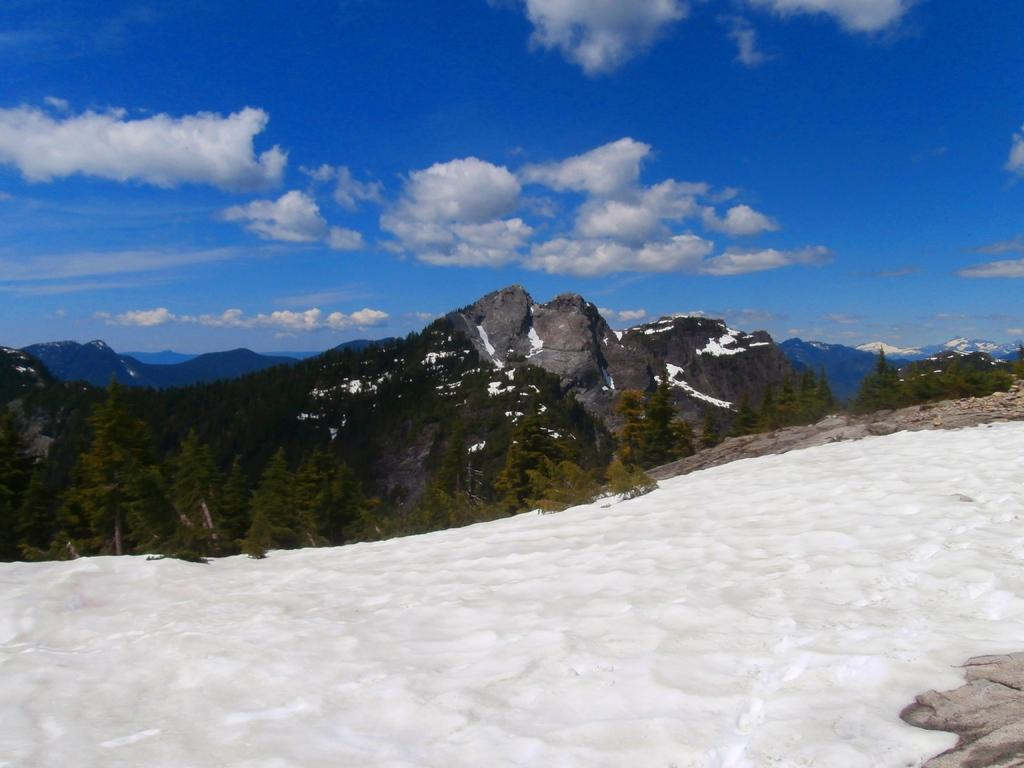What is the condition of the ground in the image? The ground in the image is covered with snow. What can be seen in the background of the image? There are trees and mountains visible in the background of the image. What type of underwear is being worn by the trees in the image? There are no people or underwear present in the image, as it features a snow-covered ground with trees and mountains in the background. 